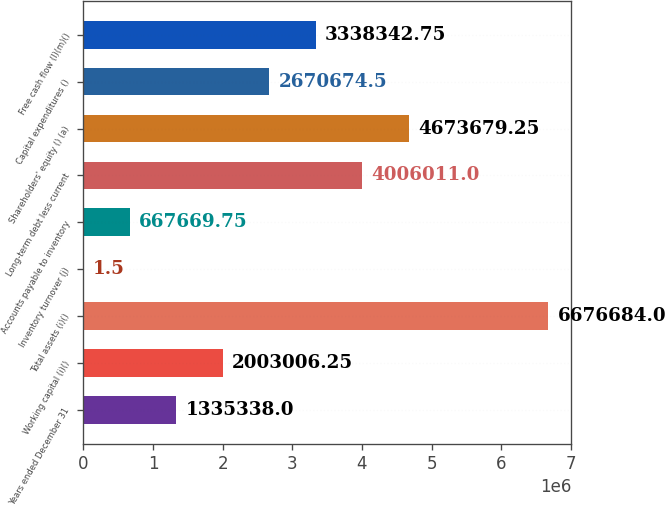Convert chart to OTSL. <chart><loc_0><loc_0><loc_500><loc_500><bar_chart><fcel>Years ended December 31<fcel>Working capital (i)()<fcel>Total assets (i)()<fcel>Inventory turnover (j)<fcel>Accounts payable to inventory<fcel>Long-term debt less current<fcel>Shareholders' equity () (a)<fcel>Capital expenditures ()<fcel>Free cash flow (l)(m)()<nl><fcel>1.33534e+06<fcel>2.00301e+06<fcel>6.67668e+06<fcel>1.5<fcel>667670<fcel>4.00601e+06<fcel>4.67368e+06<fcel>2.67067e+06<fcel>3.33834e+06<nl></chart> 